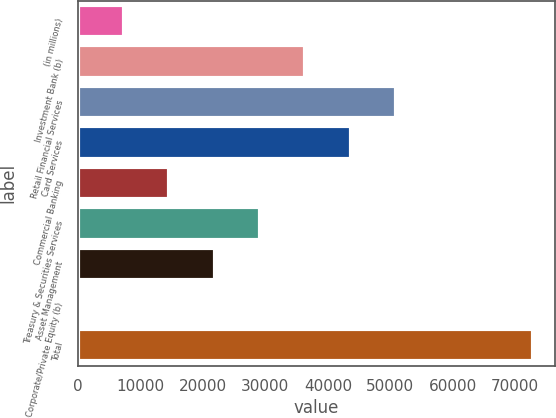<chart> <loc_0><loc_0><loc_500><loc_500><bar_chart><fcel>(in millions)<fcel>Investment Bank (b)<fcel>Retail Financial Services<fcel>Card Services<fcel>Commercial Banking<fcel>Treasury & Securities Services<fcel>Asset Management<fcel>Corporate/Private Equity (b)<fcel>Total<nl><fcel>7324<fcel>36412<fcel>50956<fcel>43684<fcel>14596<fcel>29140<fcel>21868<fcel>52<fcel>72772<nl></chart> 